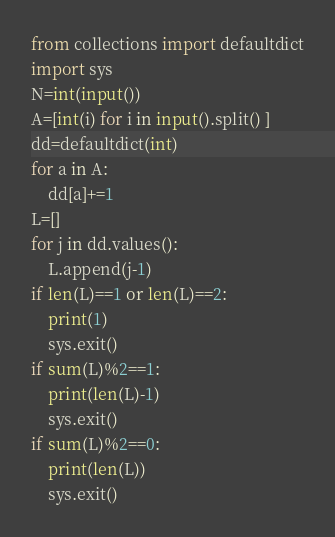<code> <loc_0><loc_0><loc_500><loc_500><_Python_>from collections import defaultdict
import sys
N=int(input())
A=[int(i) for i in input().split() ]
dd=defaultdict(int)
for a in A:
    dd[a]+=1
L=[]
for j in dd.values():
    L.append(j-1)
if len(L)==1 or len(L)==2:
    print(1)
    sys.exit()
if sum(L)%2==1:
    print(len(L)-1)
    sys.exit()
if sum(L)%2==0:
    print(len(L))
    sys.exit()</code> 